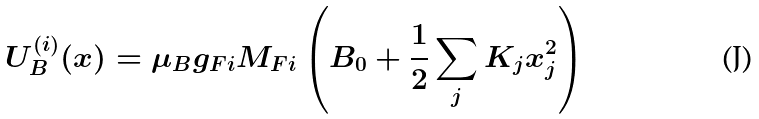<formula> <loc_0><loc_0><loc_500><loc_500>U _ { B } ^ { ( i ) } ( { x } ) = \mu _ { B } g _ { F i } M _ { F i } \left ( B _ { 0 } + \frac { 1 } { 2 } \sum _ { j } K _ { j } x ^ { 2 } _ { j } \right )</formula> 